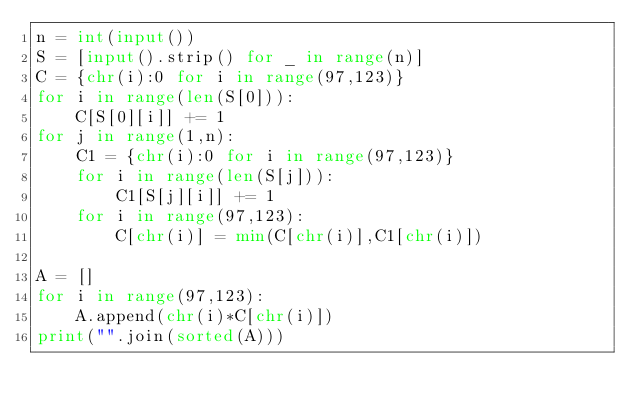Convert code to text. <code><loc_0><loc_0><loc_500><loc_500><_Python_>n = int(input())
S = [input().strip() for _ in range(n)]
C = {chr(i):0 for i in range(97,123)}
for i in range(len(S[0])):
    C[S[0][i]] += 1
for j in range(1,n):
    C1 = {chr(i):0 for i in range(97,123)}
    for i in range(len(S[j])):
        C1[S[j][i]] += 1
    for i in range(97,123):
        C[chr(i)] = min(C[chr(i)],C1[chr(i)])
        
A = []
for i in range(97,123):
    A.append(chr(i)*C[chr(i)])
print("".join(sorted(A)))</code> 